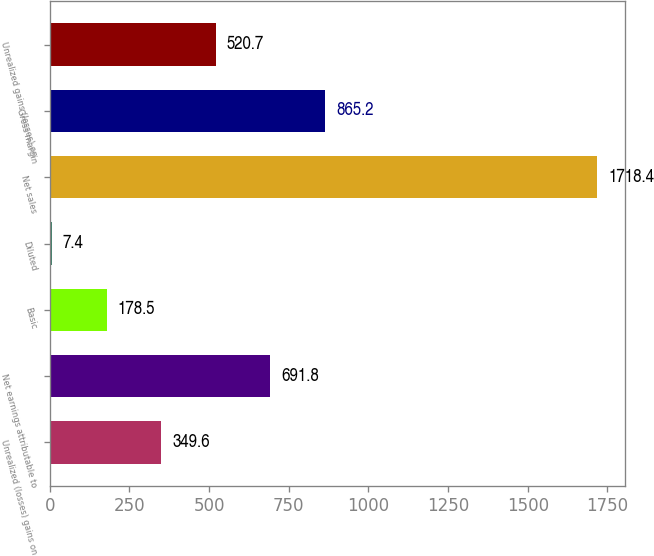Convert chart. <chart><loc_0><loc_0><loc_500><loc_500><bar_chart><fcel>Unrealized (losses) gains on<fcel>Net earnings attributable to<fcel>Basic<fcel>Diluted<fcel>Net sales<fcel>Gross margin<fcel>Unrealized gains (losses) on<nl><fcel>349.6<fcel>691.8<fcel>178.5<fcel>7.4<fcel>1718.4<fcel>865.2<fcel>520.7<nl></chart> 